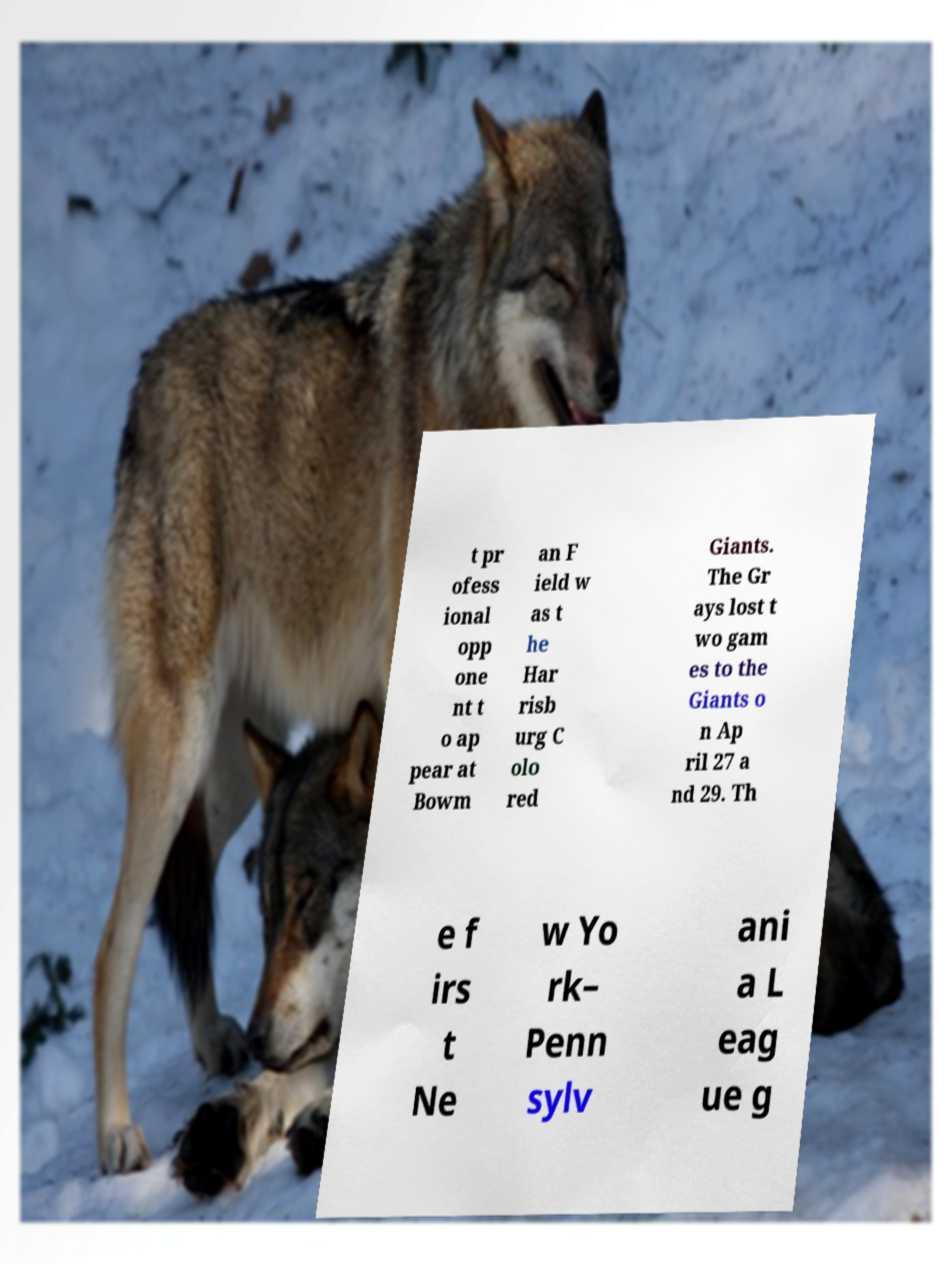For documentation purposes, I need the text within this image transcribed. Could you provide that? t pr ofess ional opp one nt t o ap pear at Bowm an F ield w as t he Har risb urg C olo red Giants. The Gr ays lost t wo gam es to the Giants o n Ap ril 27 a nd 29. Th e f irs t Ne w Yo rk– Penn sylv ani a L eag ue g 